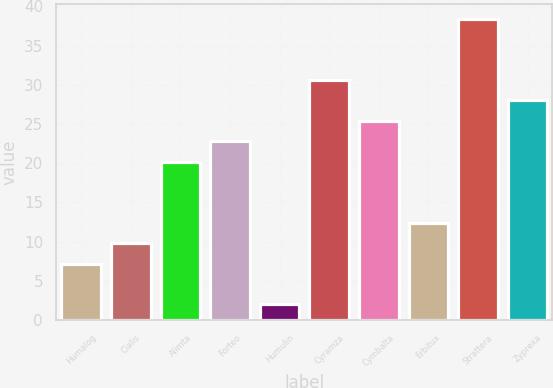Convert chart. <chart><loc_0><loc_0><loc_500><loc_500><bar_chart><fcel>Humalog<fcel>Cialis<fcel>Alimta<fcel>Forteo<fcel>Humulin<fcel>Cyramza<fcel>Cymbalta<fcel>Erbitux<fcel>Strattera<fcel>Zyprexa<nl><fcel>7.2<fcel>9.8<fcel>20.2<fcel>22.8<fcel>2<fcel>30.6<fcel>25.4<fcel>12.4<fcel>38.4<fcel>28<nl></chart> 